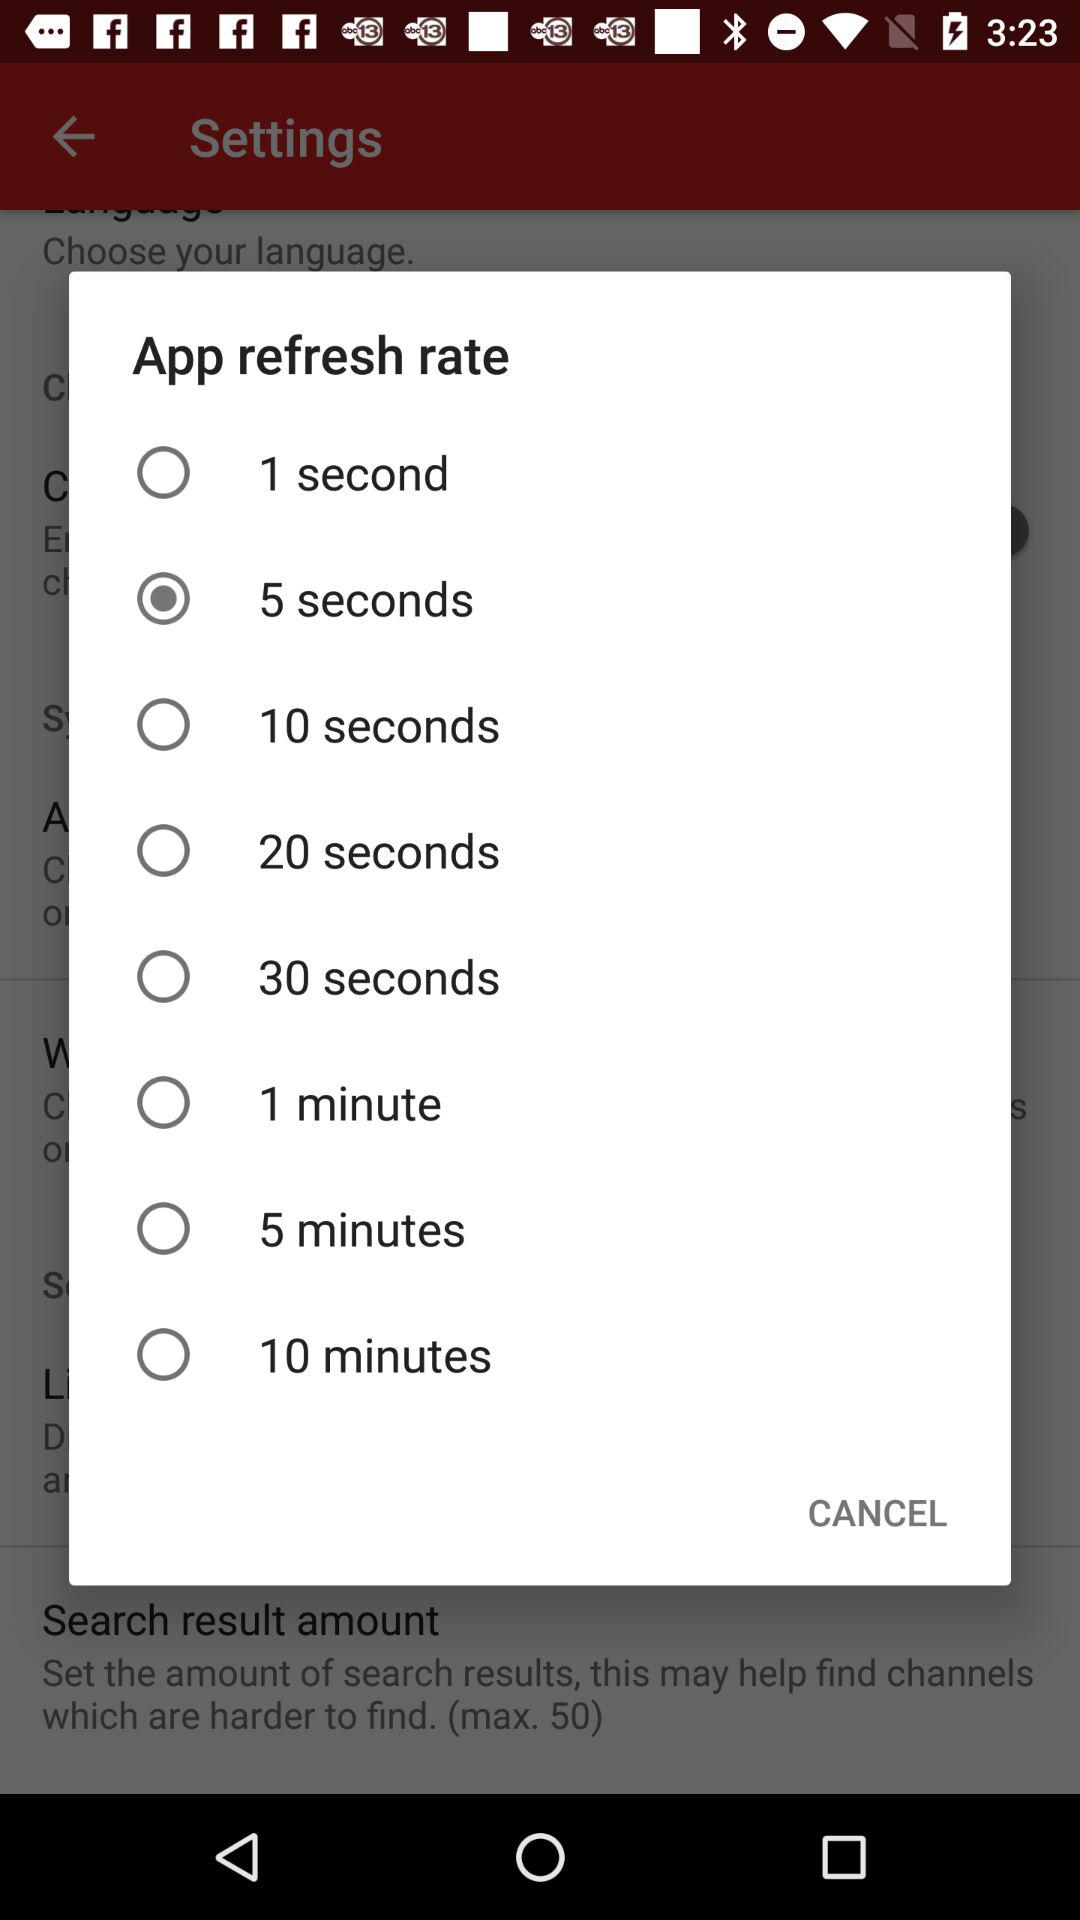What is the selected app refresh rate? The selected app refresh rate is "5 seconds". 